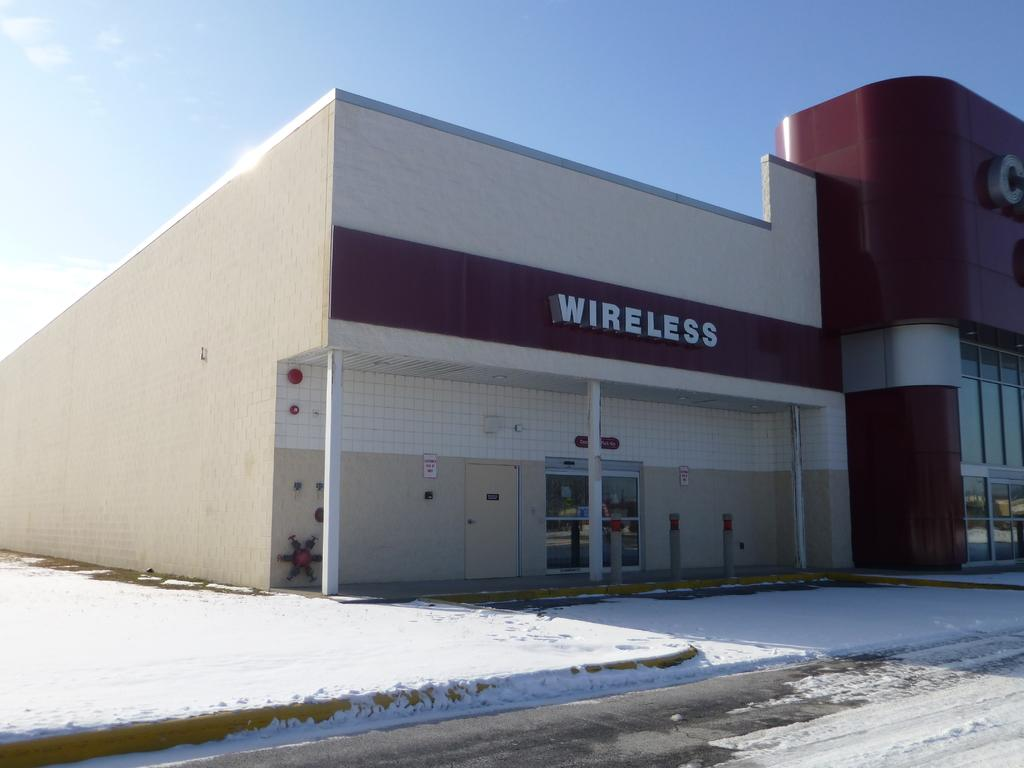What type of structure is in the image? There is a building in the image. What is covering the ground in the image? There is snow at the bottom of the image. Can you describe a specific feature of the building? There is a door visible in the image. What material is present in the middle of the image? Glass is present in the middle of the image. What architectural elements can be seen in the image? There are pillars in the image. What is visible at the top of the image? The sky is visible at the top of the image. What word is written on the honey in the image? There is no honey or word present in the image. 